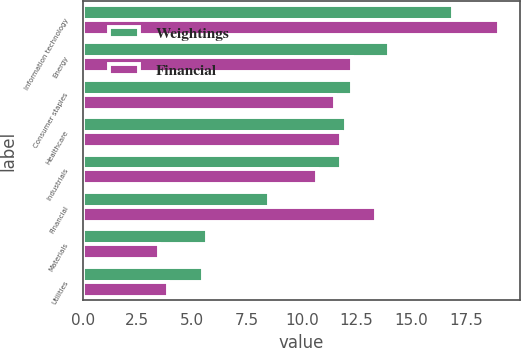Convert chart. <chart><loc_0><loc_0><loc_500><loc_500><stacked_bar_chart><ecel><fcel>Information technology<fcel>Energy<fcel>Consumer staples<fcel>Healthcare<fcel>Industrials<fcel>Financial<fcel>Materials<fcel>Utilities<nl><fcel>Weightings<fcel>16.9<fcel>14<fcel>12.3<fcel>12<fcel>11.8<fcel>8.5<fcel>5.7<fcel>5.5<nl><fcel>Financial<fcel>19<fcel>12.3<fcel>11.5<fcel>11.8<fcel>10.7<fcel>13.4<fcel>3.5<fcel>3.9<nl></chart> 